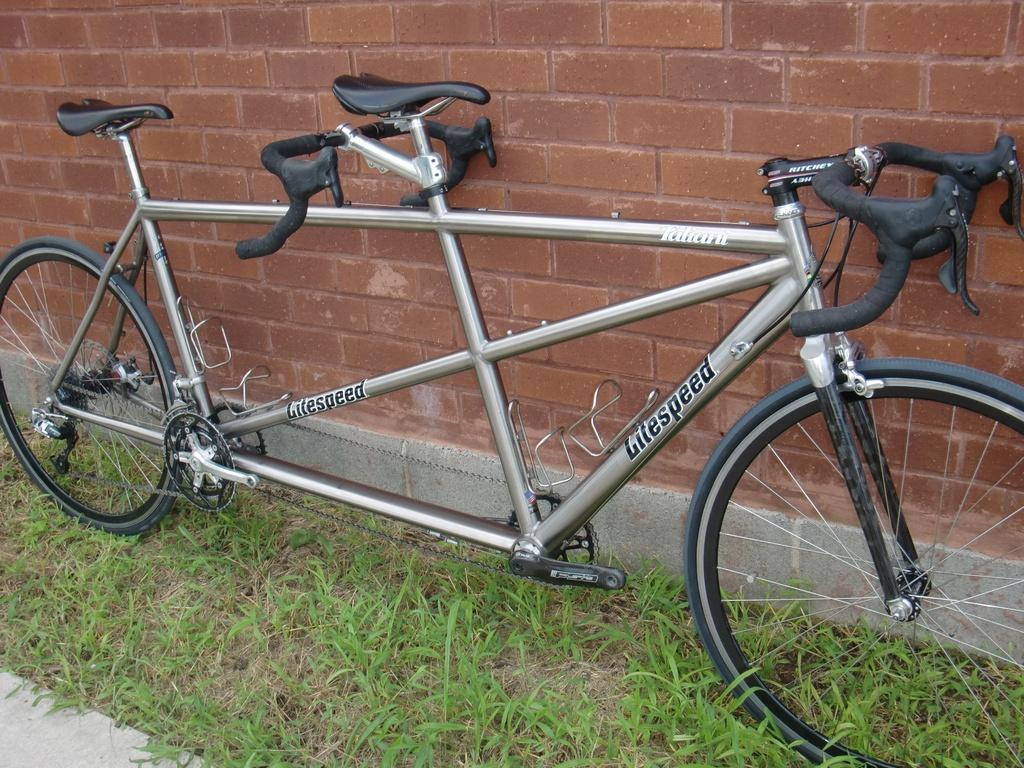What is the main subject of the image? The main subject of the image is a vehicle. Can you describe the color of the vehicle? The vehicle is in ash and black color. How many seats are in the vehicle? The vehicle has two seats. What type of vegetation can be seen in the image? There is green grass in the image. What is the color of the wall in the image? The wall in the image is brown in color. What type of lace can be seen hanging from the vehicle in the image? There is no lace present in the image; it features a vehicle with two seats and a brown wall in the background. What type of mine is visible in the image? There is no mine present in the image; it features a vehicle, green grass, and a brown wall. 